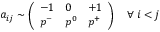<formula> <loc_0><loc_0><loc_500><loc_500>a _ { i j } \sim \left ( \begin{array} { l l l } { - 1 } & { 0 } & { + 1 } \\ { p ^ { - } } & { p ^ { 0 } } & { p ^ { + } } \end{array} \right ) \quad \forall \, i < j</formula> 